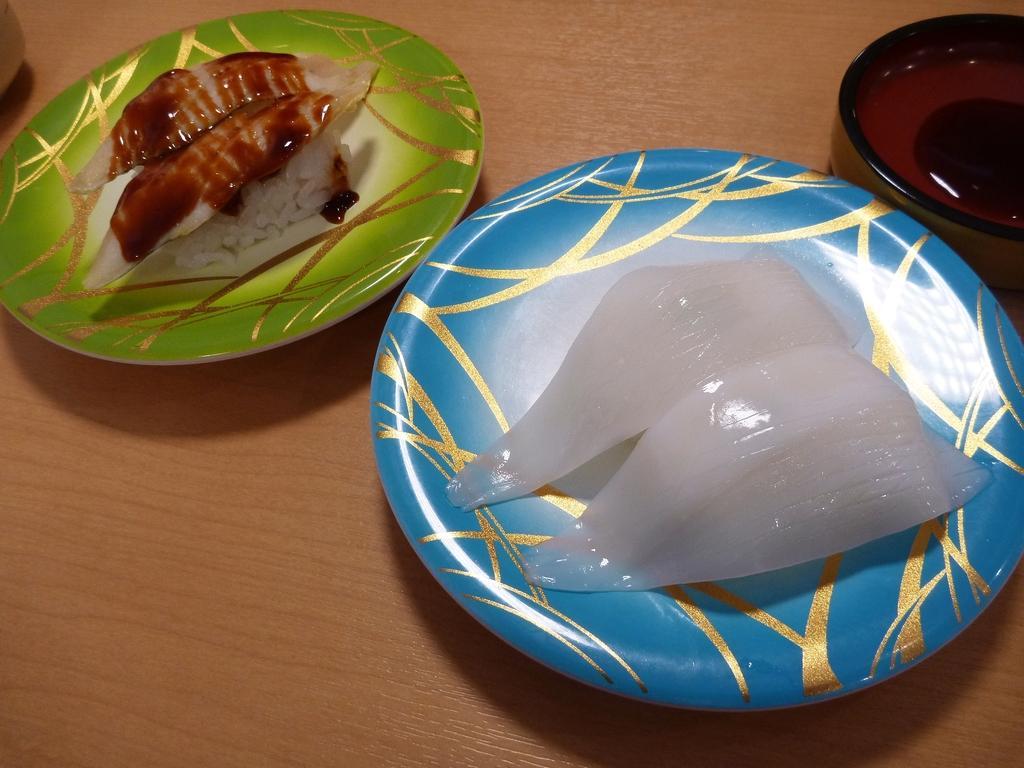Can you describe this image briefly? In this image in the center there are two plates, and in the plates there is food. And on the right side and left side there are bowls. At the bottom it looks like a table. 